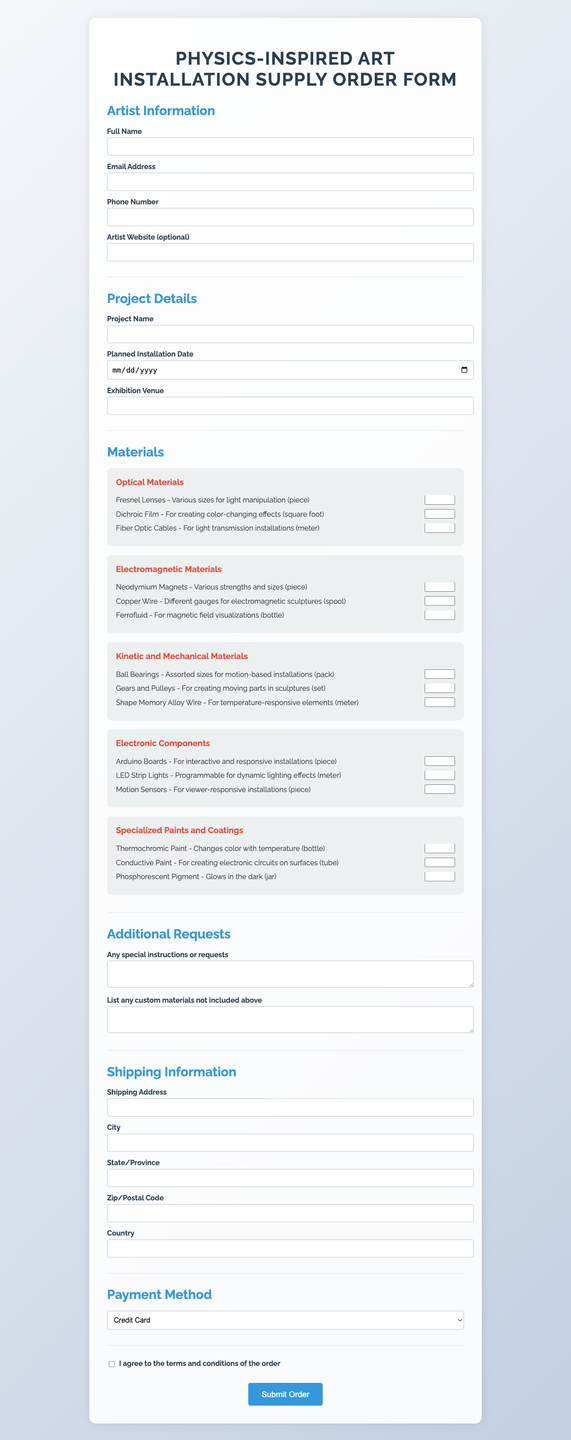what is the title of the form? The title of the form is specified at the top of the document.
Answer: Physics-Inspired Art Installation Supply Order Form what is the artist's name field? The name field is provided to collect the artist's full name for the order.
Answer: Full Name what materials are listed under Optical Materials? This question requires looking at the materials specified in the Optical Materials category.
Answer: Fresnel Lenses, Dichroic Film, Fiber Optic Cables how many items are there in the Kinetic and Mechanical Materials section? The total number of items can be determined by counting listed materials in that section.
Answer: 3 what is the unit for Dichroic Film? This question focuses on the specific unit of measurement for a particular material.
Answer: square foot which payment method is available for the order? This question asks to identify the payment methods listed in the document.
Answer: Credit Card what is required before submitting the order? The necessary action that must be taken prior to order submission is mentioned in the terms section.
Answer: Agree to terms and conditions what additional information can be provided under additional requests? This query aims to find out what kind of information can be specified in that section.
Answer: Special instructions or custom materials when is the planned installation date? The planned installation date field lets the artist specify when the installation will take place.
Answer: Planned Installation Date 